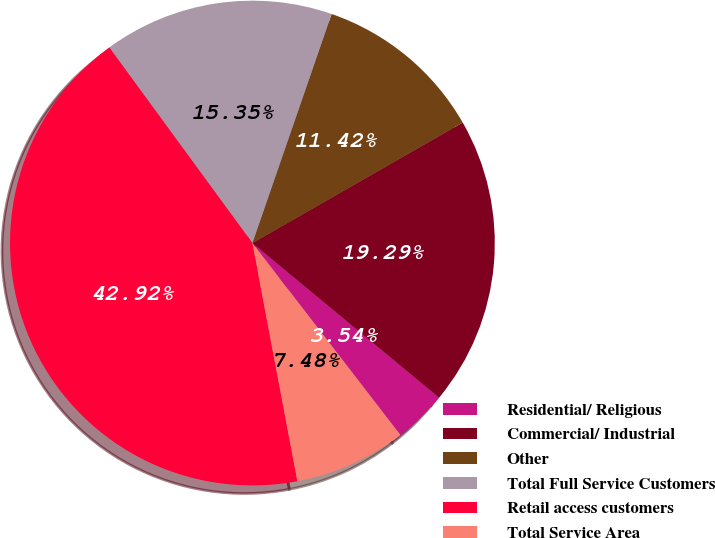<chart> <loc_0><loc_0><loc_500><loc_500><pie_chart><fcel>Residential/ Religious<fcel>Commercial/ Industrial<fcel>Other<fcel>Total Full Service Customers<fcel>Retail access customers<fcel>Total Service Area<nl><fcel>3.54%<fcel>19.29%<fcel>11.42%<fcel>15.35%<fcel>42.92%<fcel>7.48%<nl></chart> 